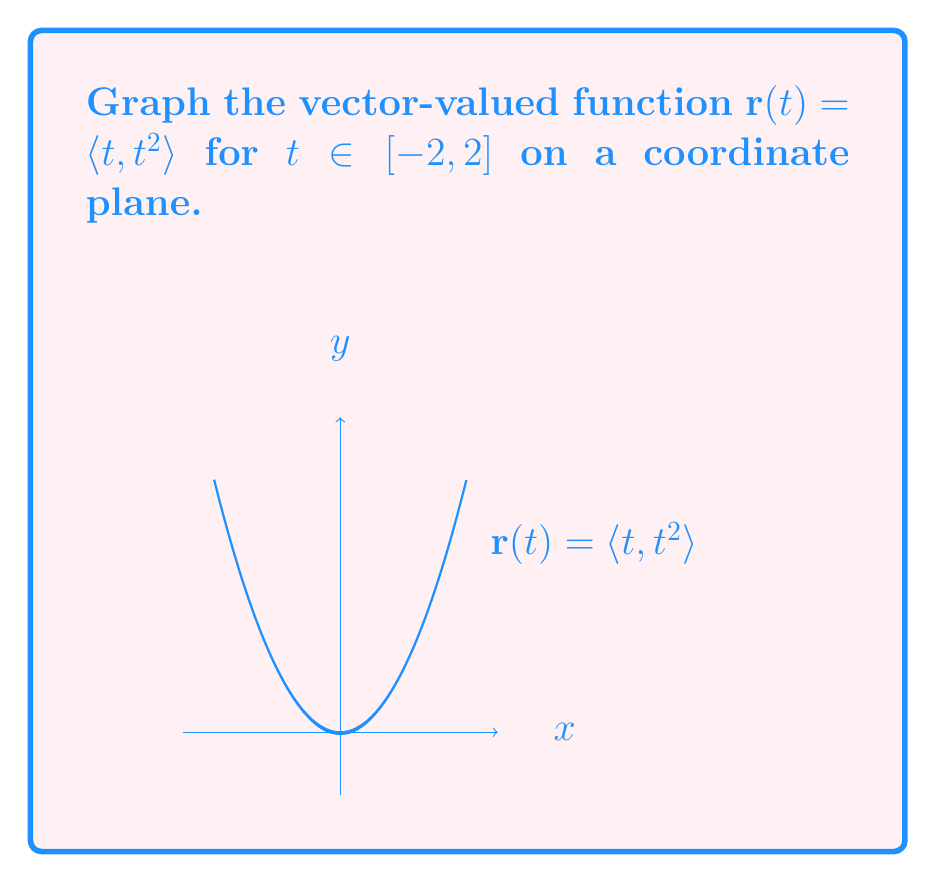Can you answer this question? To graph the vector-valued function $\mathbf{r}(t) = \langle t, t^2 \rangle$:

1) Understand the components:
   - $x = t$
   - $y = t^2$

2) Make a table of points:
   For $t = -2, -1, 0, 1, 2$:
   $(-2, 4), (-1, 1), (0, 0), (1, 1), (2, 4)$

3) Plot these points on the coordinate plane.

4) Connect the points with a smooth curve.

5) The resulting graph is a parabola opening upward, with vertex at (0,0).

6) The domain $[-2, 2]$ means the graph extends from $x = -2$ to $x = 2$.

This function traces the path of a parabola $y = x^2$ from left to right as $t$ increases from -2 to 2.
Answer: Parabola $y = x^2$ from $(-2, 4)$ to $(2, 4)$ 